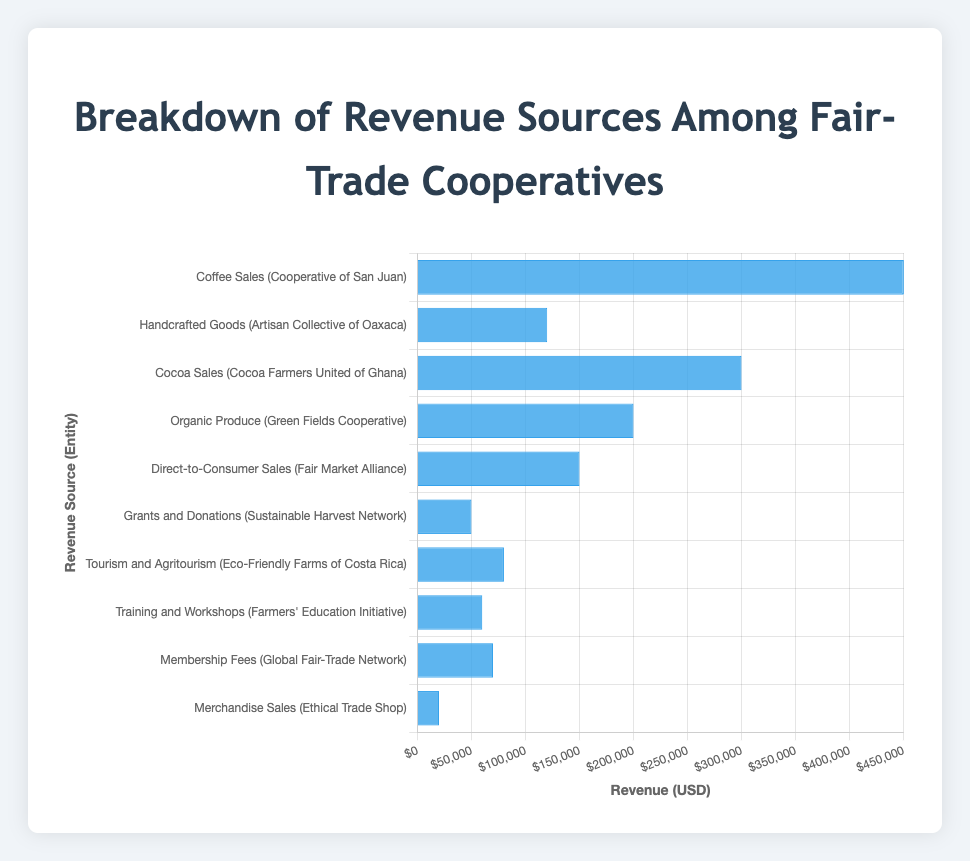What is the revenue amount from Coffee Sales? The bar labeled 'Coffee Sales (Cooperative of San Juan)' shows the height corresponding to $450,000.
Answer: $450,000 Which revenue source generates the highest revenue? The highest bar corresponds to 'Coffee Sales (Cooperative of San Juan)', which has a revenue amount of $450,000.
Answer: Coffee Sales Which two revenue sources combined generate exactly $500,000? By examining the bars, 'Grants and Donations (Sustainable Harvest Network)' generates $50,000, and 'Organic Produce (Green Fields Cooperative)' generates $200,000, so $50,000 + $200,000 = $250,000. We search for another combination such as 'Handcrafted Goods (Artisan Collective of Oaxaca)' $120,000 and 'Direct-to-Consumer Sales (Fair Market Alliance)' $150,000 summing to $270,000. However, 'Merchandise Sales (Ethical Trade Shop)' $20,000 and 'Cocoa Sales (Cocoa Farmers United of Ghana)' $300,000 add up to $320,000. None achieve exactly $500,000.
Answer: None How does the revenue from Tourism and Agritourism compare to Membership Fees? The bar for 'Tourism and Agritourism (Eco-Friendly Farms of Costa Rica)' shows $80,000, whereas the bar for 'Membership Fees (Global Fair-Trade Network)' shows $70,000.
Answer: Tourism and Agritourism generates more revenue What is the visual indicator of the highest revenue source? The visual indicator of the highest revenue source is the tallest bar on the graph which is 'Coffee Sales (Cooperative of San Juan)'.
Answer: Tallest bar What is the total revenue from all sources? Adding up all the revenue amounts: $450,000 + $120,000 + $300,000 + $200,000 + $150,000 + $50,000 + $80,000 + $60,000 + $70,000 + $20,000 = $1,500,000.
Answer: $1,500,000 Which revenue source generates the least revenue? The shortest bar corresponds to 'Merchandise Sales (Ethical Trade Shop)' generating $20,000.
Answer: Merchandise Sales What is the average revenue generated by the cooperatives? Summing all revenues gives $1,500,000. There are 10 revenue sources, so the average is $1,500,000 / 10 = $150,000.
Answer: $150,000 What is the combined revenue from Handcrafted Goods and Training and Workshops? The revenue from 'Handcrafted Goods (Artisan Collective of Oaxaca)' is $120,000 and from 'Training and Workshops (Farmers' Education Initiative)' is $60,000. Combined revenue is $120,000 + $60,000 = $180,000.
Answer: $180,000 How does the revenue from Direct-to-Consumer Sales compare to Cocoa Sales? 'Direct-to-Consumer Sales (Fair Market Alliance)' shows $150,000, whereas 'Cocoa Sales (Cocoa Farmers United of Ghana)' shows $300,000.
Answer: Cocoa Sales generates more revenue 